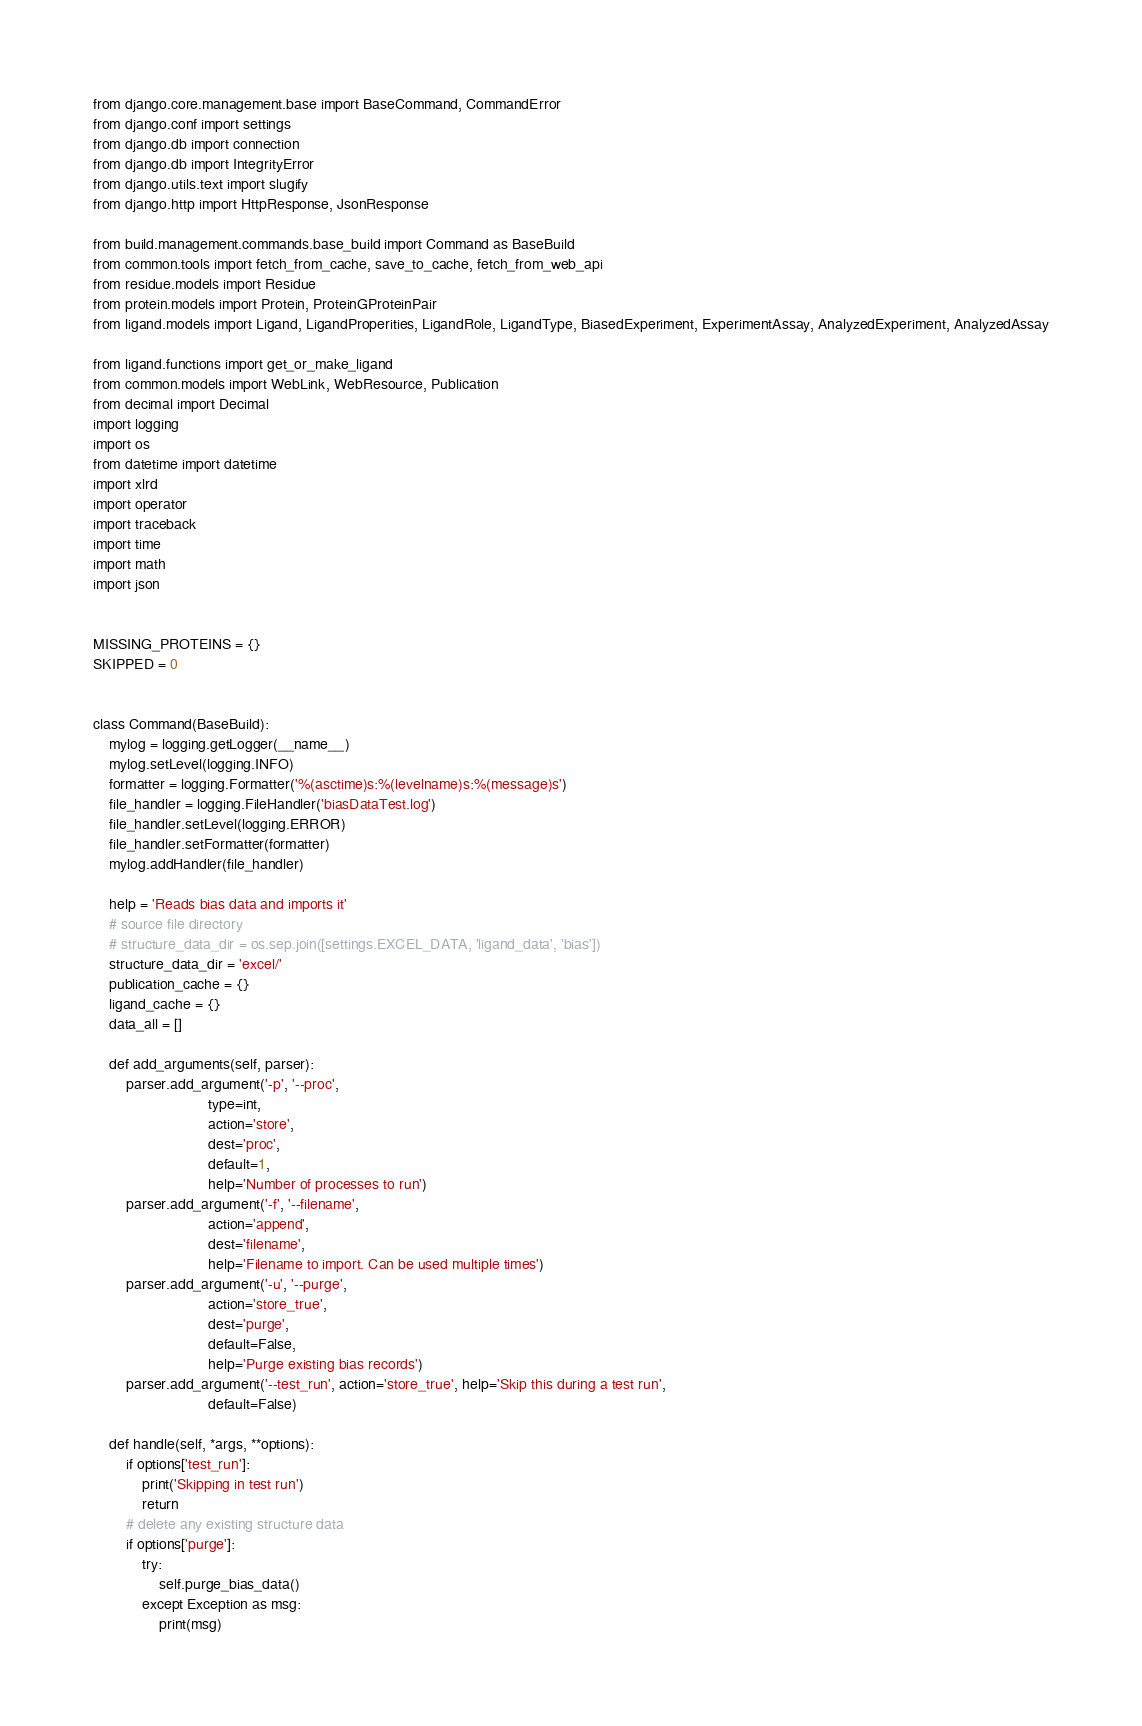Convert code to text. <code><loc_0><loc_0><loc_500><loc_500><_Python_>from django.core.management.base import BaseCommand, CommandError
from django.conf import settings
from django.db import connection
from django.db import IntegrityError
from django.utils.text import slugify
from django.http import HttpResponse, JsonResponse

from build.management.commands.base_build import Command as BaseBuild
from common.tools import fetch_from_cache, save_to_cache, fetch_from_web_api
from residue.models import Residue
from protein.models import Protein, ProteinGProteinPair
from ligand.models import Ligand, LigandProperities, LigandRole, LigandType, BiasedExperiment, ExperimentAssay, AnalyzedExperiment, AnalyzedAssay

from ligand.functions import get_or_make_ligand
from common.models import WebLink, WebResource, Publication
from decimal import Decimal
import logging
import os
from datetime import datetime
import xlrd
import operator
import traceback
import time
import math
import json


MISSING_PROTEINS = {}
SKIPPED = 0


class Command(BaseBuild):
    mylog = logging.getLogger(__name__)
    mylog.setLevel(logging.INFO)
    formatter = logging.Formatter('%(asctime)s:%(levelname)s:%(message)s')
    file_handler = logging.FileHandler('biasDataTest.log')
    file_handler.setLevel(logging.ERROR)
    file_handler.setFormatter(formatter)
    mylog.addHandler(file_handler)

    help = 'Reads bias data and imports it'
    # source file directory
    # structure_data_dir = os.sep.join([settings.EXCEL_DATA, 'ligand_data', 'bias'])
    structure_data_dir = 'excel/'
    publication_cache = {}
    ligand_cache = {}
    data_all = []

    def add_arguments(self, parser):
        parser.add_argument('-p', '--proc',
                            type=int,
                            action='store',
                            dest='proc',
                            default=1,
                            help='Number of processes to run')
        parser.add_argument('-f', '--filename',
                            action='append',
                            dest='filename',
                            help='Filename to import. Can be used multiple times')
        parser.add_argument('-u', '--purge',
                            action='store_true',
                            dest='purge',
                            default=False,
                            help='Purge existing bias records')
        parser.add_argument('--test_run', action='store_true', help='Skip this during a test run',
                            default=False)

    def handle(self, *args, **options):
        if options['test_run']:
            print('Skipping in test run')
            return
        # delete any existing structure data
        if options['purge']:
            try:
                self.purge_bias_data()
            except Exception as msg:
                print(msg)</code> 